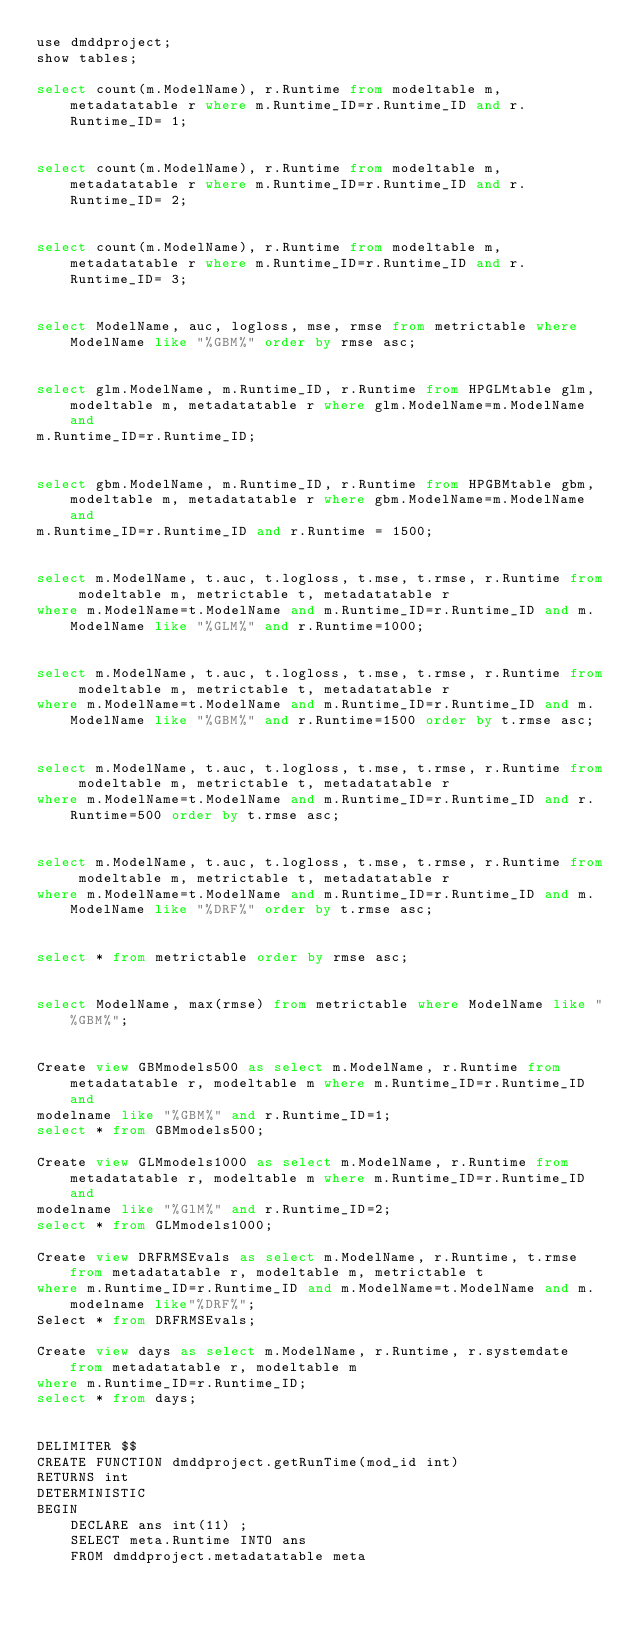Convert code to text. <code><loc_0><loc_0><loc_500><loc_500><_SQL_>use dmddproject;
show tables;

select count(m.ModelName), r.Runtime from modeltable m, metadatatable r where m.Runtime_ID=r.Runtime_ID and r.Runtime_ID= 1;


select count(m.ModelName), r.Runtime from modeltable m, metadatatable r where m.Runtime_ID=r.Runtime_ID and r.Runtime_ID= 2;


select count(m.ModelName), r.Runtime from modeltable m, metadatatable r where m.Runtime_ID=r.Runtime_ID and r.Runtime_ID= 3;


select ModelName, auc, logloss, mse, rmse from metrictable where ModelName like "%GBM%" order by rmse asc;


select glm.ModelName, m.Runtime_ID, r.Runtime from HPGLMtable glm, modeltable m, metadatatable r where glm.ModelName=m.ModelName and 
m.Runtime_ID=r.Runtime_ID;


select gbm.ModelName, m.Runtime_ID, r.Runtime from HPGBMtable gbm, modeltable m, metadatatable r where gbm.ModelName=m.ModelName and 
m.Runtime_ID=r.Runtime_ID and r.Runtime = 1500; 


select m.ModelName, t.auc, t.logloss, t.mse, t.rmse, r.Runtime from modeltable m, metrictable t, metadatatable r 
where m.ModelName=t.ModelName and m.Runtime_ID=r.Runtime_ID and m.ModelName like "%GLM%" and r.Runtime=1000; 
 
 
select m.ModelName, t.auc, t.logloss, t.mse, t.rmse, r.Runtime from modeltable m, metrictable t, metadatatable r 
where m.ModelName=t.ModelName and m.Runtime_ID=r.Runtime_ID and m.ModelName like "%GBM%" and r.Runtime=1500 order by t.rmse asc;


select m.ModelName, t.auc, t.logloss, t.mse, t.rmse, r.Runtime from modeltable m, metrictable t, metadatatable r 
where m.ModelName=t.ModelName and m.Runtime_ID=r.Runtime_ID and r.Runtime=500 order by t.rmse asc;


select m.ModelName, t.auc, t.logloss, t.mse, t.rmse, r.Runtime from modeltable m, metrictable t, metadatatable r 
where m.ModelName=t.ModelName and m.Runtime_ID=r.Runtime_ID and m.ModelName like "%DRF%" order by t.rmse asc;


select * from metrictable order by rmse asc;


select ModelName, max(rmse) from metrictable where ModelName like "%GBM%";


Create view GBMmodels500 as select m.ModelName, r.Runtime from metadatatable r, modeltable m where m.Runtime_ID=r.Runtime_ID and
modelname like "%GBM%" and r.Runtime_ID=1;
select * from GBMmodels500;

Create view GLMmodels1000 as select m.ModelName, r.Runtime from metadatatable r, modeltable m where m.Runtime_ID=r.Runtime_ID and
modelname like "%GlM%" and r.Runtime_ID=2;
select * from GLMmodels1000;

Create view DRFRMSEvals as select m.ModelName, r.Runtime, t.rmse from metadatatable r, modeltable m, metrictable t 
where m.Runtime_ID=r.Runtime_ID and m.ModelName=t.ModelName and m.modelname like"%DRF%"; 
Select * from DRFRMSEvals;

Create view days as select m.ModelName, r.Runtime, r.systemdate from metadatatable r, modeltable m
where m.Runtime_ID=r.Runtime_ID;
select * from days;


DELIMITER $$
CREATE FUNCTION dmddproject.getRunTime(mod_id int)  
RETURNS int   
DETERMINISTIC 
BEGIN
	DECLARE ans int(11) ;	
	SELECT meta.Runtime INTO ans
    FROM dmddproject.metadatatable meta </code> 